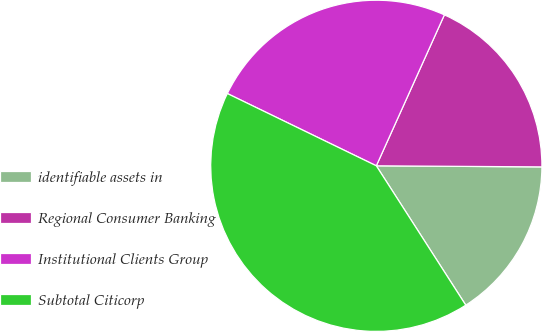Convert chart. <chart><loc_0><loc_0><loc_500><loc_500><pie_chart><fcel>identifiable assets in<fcel>Regional Consumer Banking<fcel>Institutional Clients Group<fcel>Subtotal Citicorp<nl><fcel>15.81%<fcel>18.36%<fcel>24.55%<fcel>41.27%<nl></chart> 